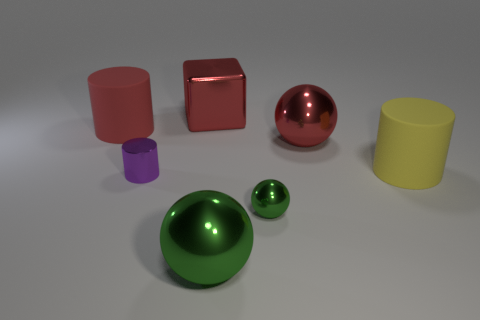Add 2 large red rubber cylinders. How many objects exist? 9 Subtract all green balls. How many balls are left? 1 Subtract all red cylinders. How many cylinders are left? 2 Subtract 2 balls. How many balls are left? 1 Subtract all cyan balls. Subtract all gray cylinders. How many balls are left? 3 Add 2 small balls. How many small balls exist? 3 Subtract 0 brown balls. How many objects are left? 7 Subtract all cubes. How many objects are left? 6 Subtract all red cubes. How many red spheres are left? 1 Subtract all big yellow objects. Subtract all spheres. How many objects are left? 3 